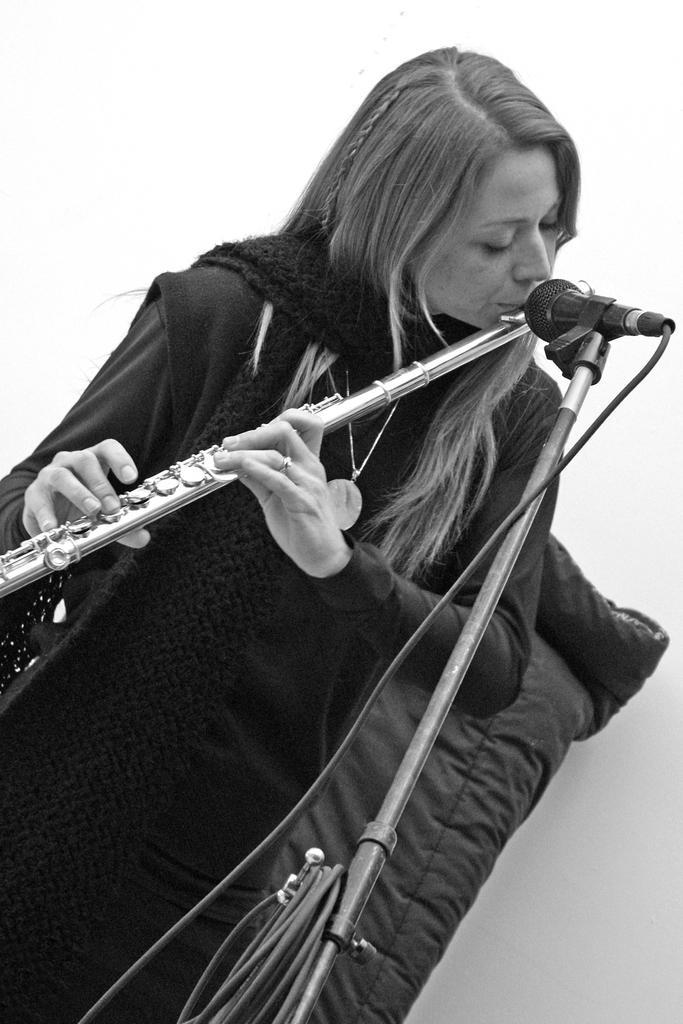Describe this image in one or two sentences. In this image a lady is playing a flute. In front of her there is a mic. She is wearing a scarf and a jacket. 